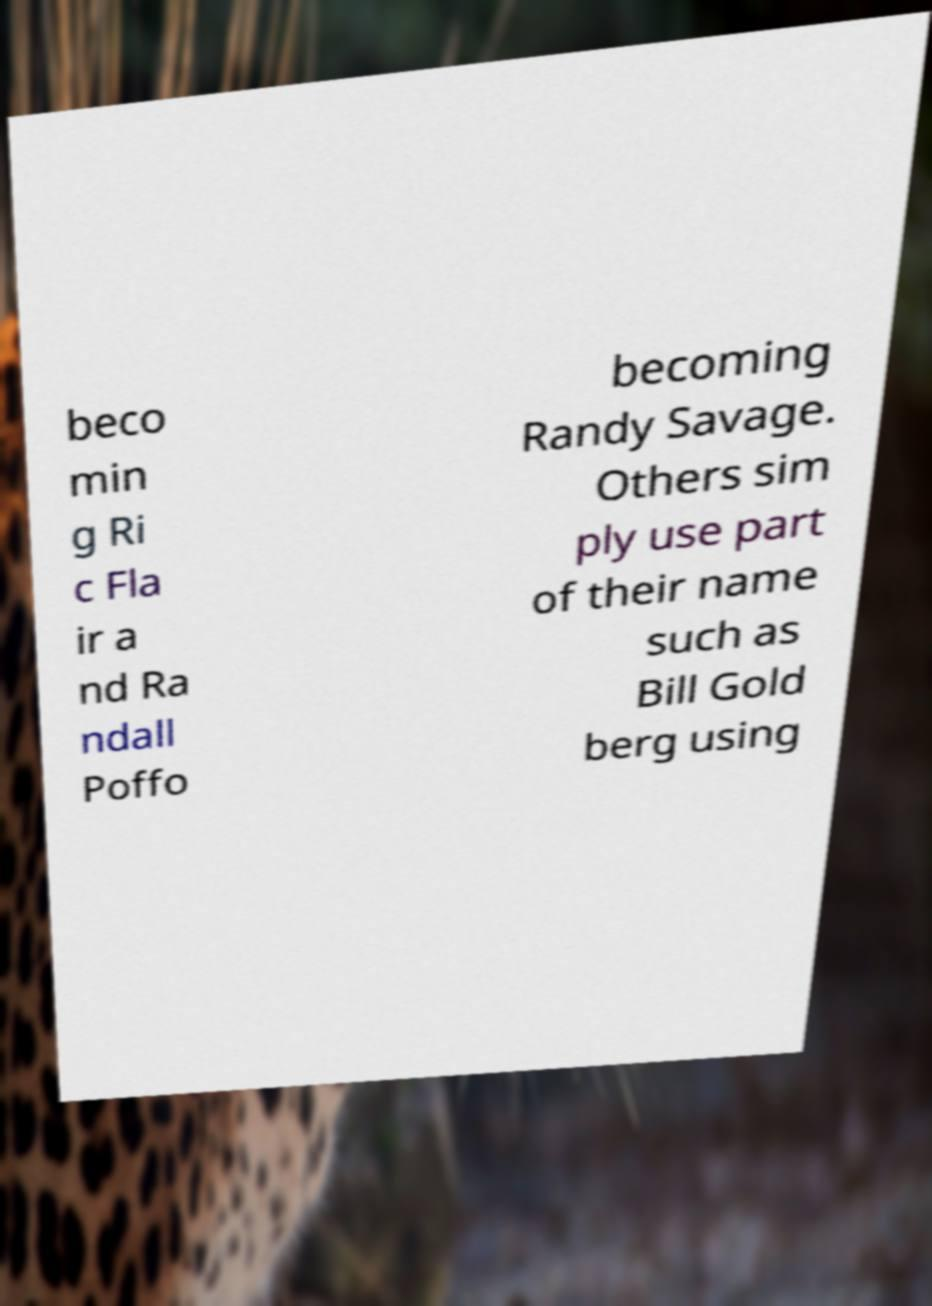Could you assist in decoding the text presented in this image and type it out clearly? beco min g Ri c Fla ir a nd Ra ndall Poffo becoming Randy Savage. Others sim ply use part of their name such as Bill Gold berg using 